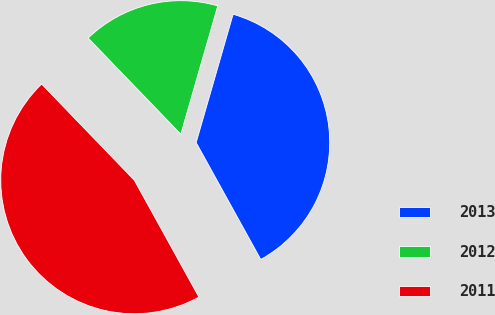<chart> <loc_0><loc_0><loc_500><loc_500><pie_chart><fcel>2013<fcel>2012<fcel>2011<nl><fcel>37.5%<fcel>16.67%<fcel>45.83%<nl></chart> 